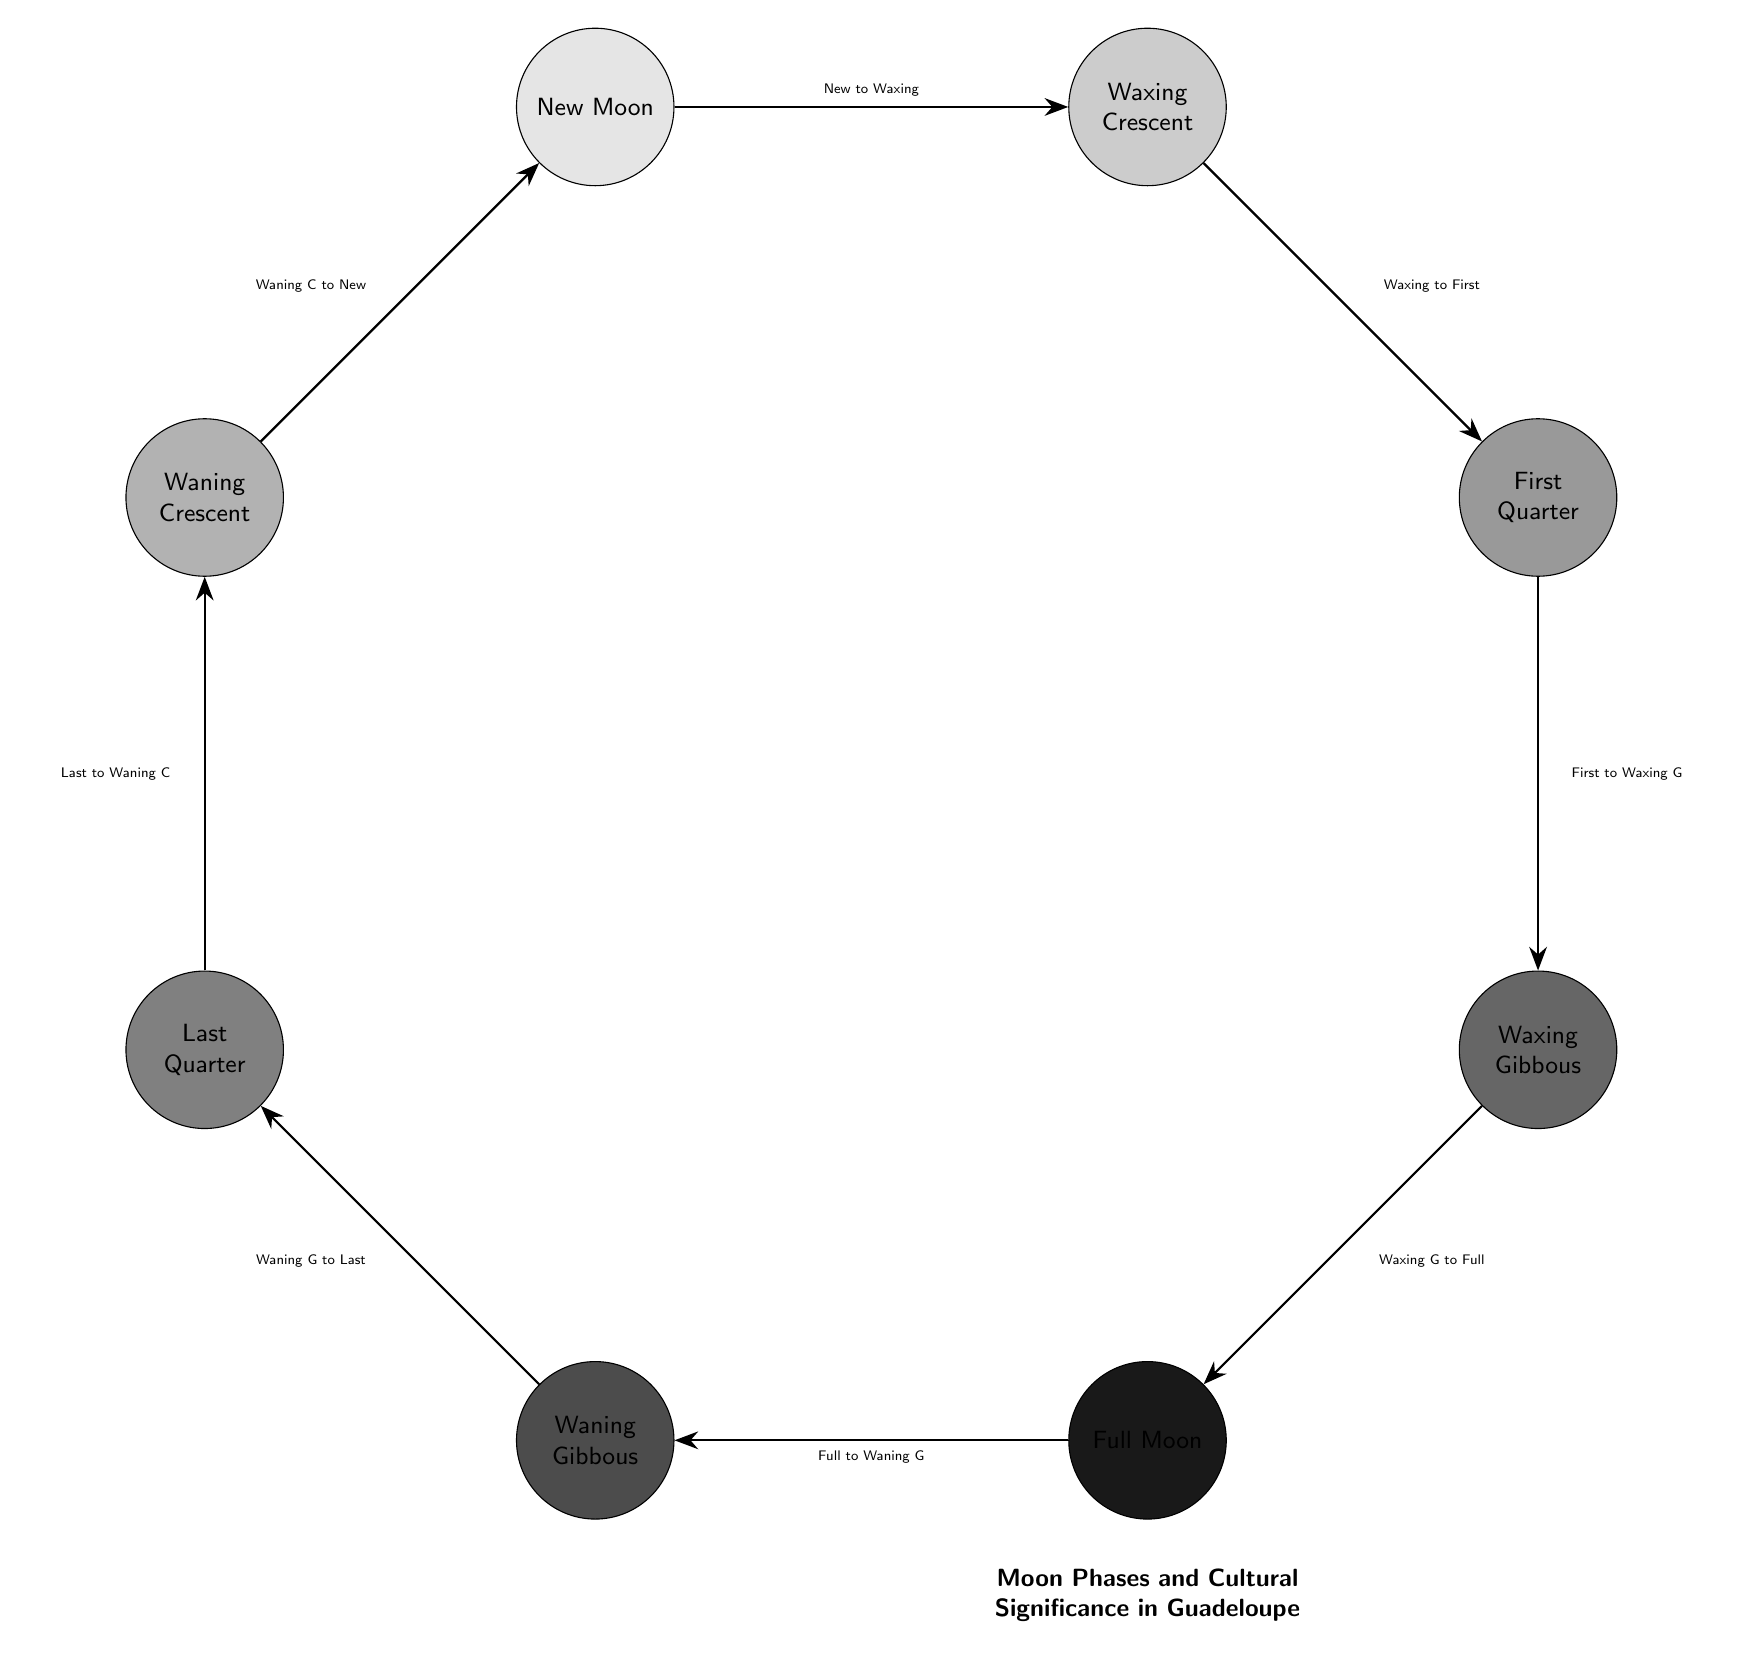What is the first phase of the Moon shown in the diagram? The diagram clearly labels the first phase as "New Moon" at the top.
Answer: New Moon How many phases of the Moon are represented in the diagram? There are eight nodes representing the phases of the Moon: New Moon, Waxing Crescent, First Quarter, Waxing Gibbous, Full Moon, Waning Gibbous, Last Quarter, and Waning Crescent.
Answer: Eight Which phase comes directly after the Waxing Crescent? The arrow from Waxing Crescent points to First Quarter, indicating it is the next phase in the sequence.
Answer: First Quarter What is the last phase before returning to the New Moon? Tracing the flow from the Full Moon to Waning Gibbous, then to Last Quarter, followed by Waning Crescent, leads to New Moon. Hence, the last phase before New Moon is Waning Crescent.
Answer: Waning Crescent Which phase has the most light depicted in the diagram? The Full Moon phase is depicted with the most light, being fully illuminated and centrally located in the diagram.
Answer: Full Moon Which two phases are directly connected by the arrow labeled "Full to Waning G"? The phases connected by the arrow that reads "Full to Waning G" are Full Moon and Waning Gibbous.
Answer: Full Moon and Waning Gibbous If you start at the New Moon, how many phases do you pass through to get to the Full Moon? From New Moon, you pass through Waxing Crescent, First Quarter, and Waxing Gibbous to reach Full Moon, totaling three phases.
Answer: Three Which phase transitions directly to the Last Quarter? The arrow from Waning Gibbous points directly to Last Quarter, indicating the transition between these two phases.
Answer: Waning Gibbous What cultural significance is associated with the Full Moon phase? The diagram title hints at cultural significance regarding all phases; the Full Moon is iconic in many cultures, likely including significant celebrations or rituals in Guadeloupe. This answer requires more contextual knowledge outside the diagram itself.
Answer: Cultural significance (context-dependent) 